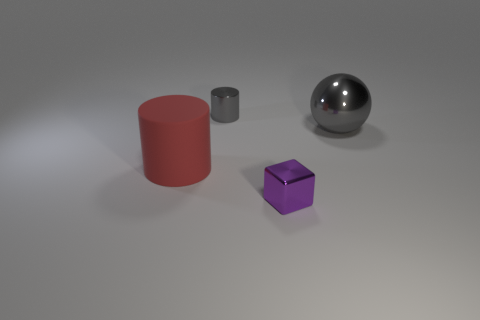Add 3 big metallic balls. How many objects exist? 7 Subtract all gray cylinders. How many cylinders are left? 1 Subtract 0 blue cubes. How many objects are left? 4 Subtract all balls. How many objects are left? 3 Subtract all yellow blocks. Subtract all purple cylinders. How many blocks are left? 1 Subtract all cyan cylinders. How many cyan cubes are left? 0 Subtract all yellow rubber objects. Subtract all red matte objects. How many objects are left? 3 Add 2 shiny things. How many shiny things are left? 5 Add 1 tiny shiny objects. How many tiny shiny objects exist? 3 